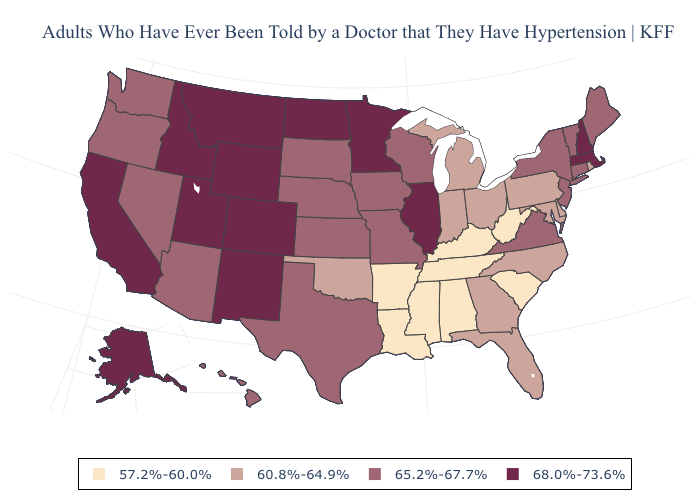Does the map have missing data?
Concise answer only. No. Does Pennsylvania have the same value as Georgia?
Give a very brief answer. Yes. What is the highest value in the South ?
Give a very brief answer. 65.2%-67.7%. Name the states that have a value in the range 65.2%-67.7%?
Keep it brief. Arizona, Connecticut, Hawaii, Iowa, Kansas, Maine, Missouri, Nebraska, Nevada, New Jersey, New York, Oregon, South Dakota, Texas, Vermont, Virginia, Washington, Wisconsin. What is the value of New Jersey?
Concise answer only. 65.2%-67.7%. Name the states that have a value in the range 65.2%-67.7%?
Answer briefly. Arizona, Connecticut, Hawaii, Iowa, Kansas, Maine, Missouri, Nebraska, Nevada, New Jersey, New York, Oregon, South Dakota, Texas, Vermont, Virginia, Washington, Wisconsin. What is the value of South Carolina?
Keep it brief. 57.2%-60.0%. What is the lowest value in the Northeast?
Answer briefly. 60.8%-64.9%. What is the highest value in the Northeast ?
Keep it brief. 68.0%-73.6%. Which states hav the highest value in the MidWest?
Answer briefly. Illinois, Minnesota, North Dakota. What is the value of North Carolina?
Write a very short answer. 60.8%-64.9%. Name the states that have a value in the range 60.8%-64.9%?
Write a very short answer. Delaware, Florida, Georgia, Indiana, Maryland, Michigan, North Carolina, Ohio, Oklahoma, Pennsylvania, Rhode Island. What is the value of Iowa?
Give a very brief answer. 65.2%-67.7%. Name the states that have a value in the range 57.2%-60.0%?
Concise answer only. Alabama, Arkansas, Kentucky, Louisiana, Mississippi, South Carolina, Tennessee, West Virginia. Name the states that have a value in the range 57.2%-60.0%?
Give a very brief answer. Alabama, Arkansas, Kentucky, Louisiana, Mississippi, South Carolina, Tennessee, West Virginia. 